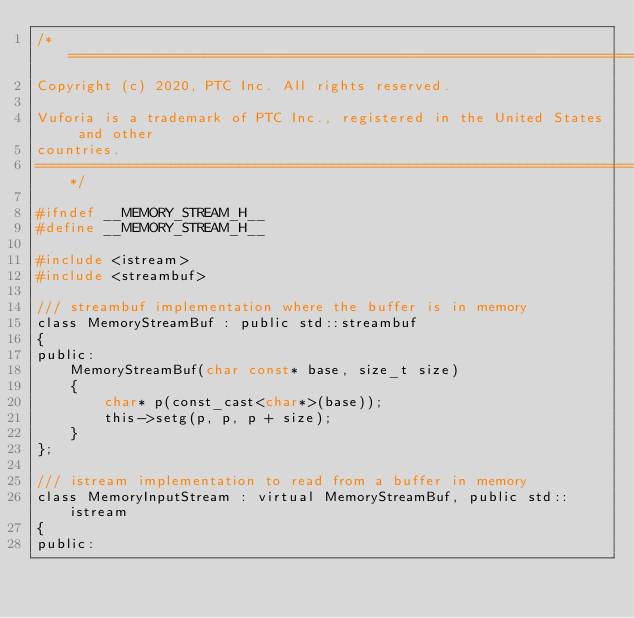<code> <loc_0><loc_0><loc_500><loc_500><_C_>/*===============================================================================
Copyright (c) 2020, PTC Inc. All rights reserved.

Vuforia is a trademark of PTC Inc., registered in the United States and other
countries.
===============================================================================*/

#ifndef __MEMORY_STREAM_H__
#define __MEMORY_STREAM_H__

#include <istream>
#include <streambuf>

/// streambuf implementation where the buffer is in memory
class MemoryStreamBuf : public std::streambuf
{
public:
    MemoryStreamBuf(char const* base, size_t size)
    {
        char* p(const_cast<char*>(base));
        this->setg(p, p, p + size);
    }
};

/// istream implementation to read from a buffer in memory
class MemoryInputStream : virtual MemoryStreamBuf, public std::istream
{
public:</code> 